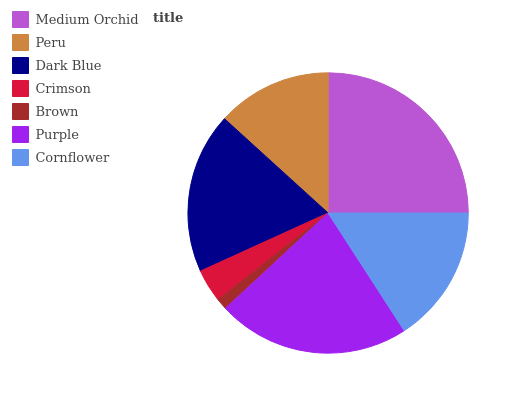Is Brown the minimum?
Answer yes or no. Yes. Is Medium Orchid the maximum?
Answer yes or no. Yes. Is Peru the minimum?
Answer yes or no. No. Is Peru the maximum?
Answer yes or no. No. Is Medium Orchid greater than Peru?
Answer yes or no. Yes. Is Peru less than Medium Orchid?
Answer yes or no. Yes. Is Peru greater than Medium Orchid?
Answer yes or no. No. Is Medium Orchid less than Peru?
Answer yes or no. No. Is Cornflower the high median?
Answer yes or no. Yes. Is Cornflower the low median?
Answer yes or no. Yes. Is Medium Orchid the high median?
Answer yes or no. No. Is Brown the low median?
Answer yes or no. No. 